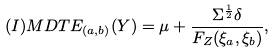Convert formula to latex. <formula><loc_0><loc_0><loc_500><loc_500>( I ) M D T E _ { ( a , b ) } ( Y ) & = \mu + \frac { \Sigma ^ { \frac { 1 } { 2 } } \delta } { F _ { Z } ( \xi _ { a } , \xi _ { b } ) } ,</formula> 